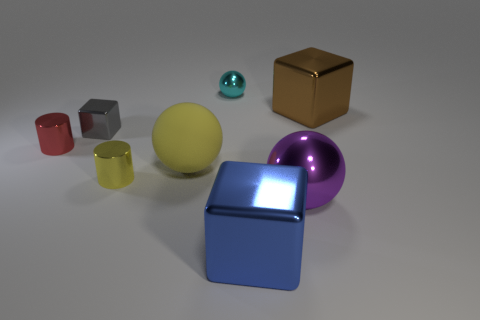The thing that is behind the large block behind the purple object is what color?
Your answer should be compact. Cyan. Are there an equal number of tiny shiny cylinders to the left of the blue cube and large things in front of the gray thing?
Your answer should be compact. No. Do the tiny red object that is on the left side of the small yellow shiny thing and the tiny cyan thing have the same material?
Keep it short and to the point. Yes. There is a metallic block that is both in front of the brown cube and behind the large shiny ball; what is its color?
Your response must be concise. Gray. There is a big metallic block that is to the right of the large blue block; what number of brown shiny things are to the right of it?
Provide a succinct answer. 0. What is the material of the yellow object that is the same shape as the tiny cyan metallic thing?
Keep it short and to the point. Rubber. The small metal ball is what color?
Provide a short and direct response. Cyan. How many objects are either matte objects or tiny brown rubber balls?
Ensure brevity in your answer.  1. What is the shape of the brown metal thing that is to the right of the yellow object left of the yellow matte thing?
Make the answer very short. Cube. What number of other objects are there of the same material as the tiny cyan object?
Your answer should be compact. 6. 